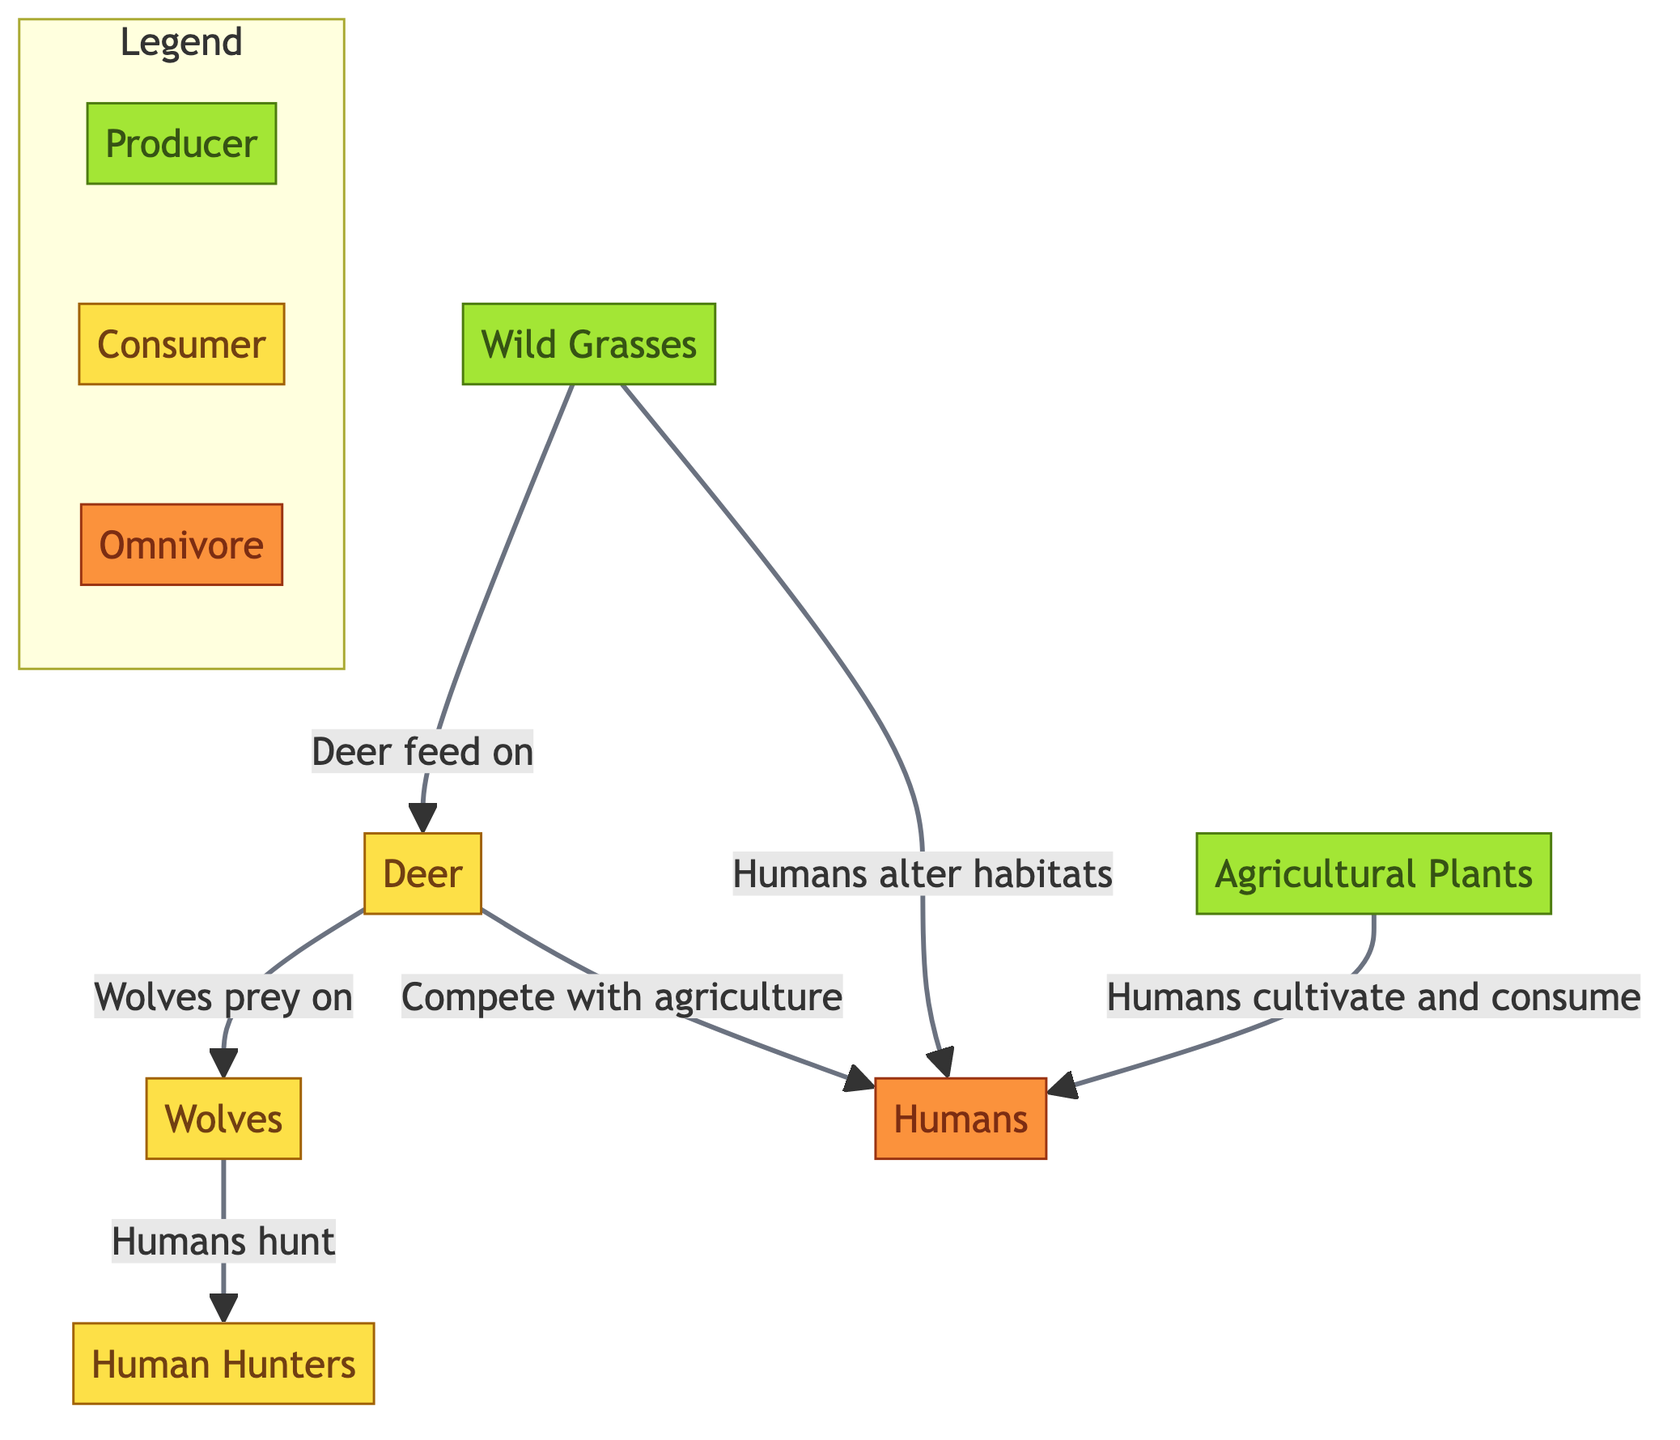What is the producer in this food chain? The diagram identifies "Wild Grasses" and "Agricultural Plants" as producers. They are placed in the first layer of the food chain, indicating their role in producing energy through photosynthesis.
Answer: Wild Grasses, Agricultural Plants How many consumer nodes are present in the diagram? The diagram depicts three distinct consumer nodes: "Deer," "Wolves," and "Human Hunters." Counting these nodes gives a total of three consumers in the food chain.
Answer: 3 Who preys on deer? According to the diagram, "Wolves" are shown as the entity that preys on "Deer." This is represented by the directed arrow indicating the predator-prey relationship between these two nodes.
Answer: Wolves What role do humans play in this food chain? Humans are classified as omnivores in the diagram, indicated by the specific label and color coding. They interact with multiple food sources in this ecosystem, including producers and consumers.
Answer: Omnivore Which two nodes have a direct competition relationship with humans? The diagram illustrates that "Deer" and "Agricultural Plants" have direct relationships with humans where "Deer" compete with agriculture, and humans cultivate "Agricultural Plants." Therefore, both compete with humans for resources.
Answer: Deer, Agricultural Plants What effect do humans have on wild grasses? The diagram indicates that humans alter habitats with a direct connection to wild grasses, implying that their activities impact the natural growth or distribution of wild grasses in the ecosystem.
Answer: Alter habitats Explain the flow of energy from producers to consumers. The flow of energy starts at the producers, "Wild Grasses" and "Agricultural Plants," which provide nutrition to "Deer." The "Deer" are then preyed upon by "Wolves," and in another connection, "Humans" also interact with "Deer" by hunting, thus representing a multi-tiered energy flow. Hence, the energy transfer progresses from producers to primary consumers and then to apex consumers.
Answer: Producers to Consumers What is the relationship between humans and agricultural plants? The relationship is characterized by human cultivation and consumption of "Agricultural Plants," showing that humans actively engage with this producer to procure food, making them a significant player in the agricultural aspect of the ecosystem.
Answer: Cultivate and consume 